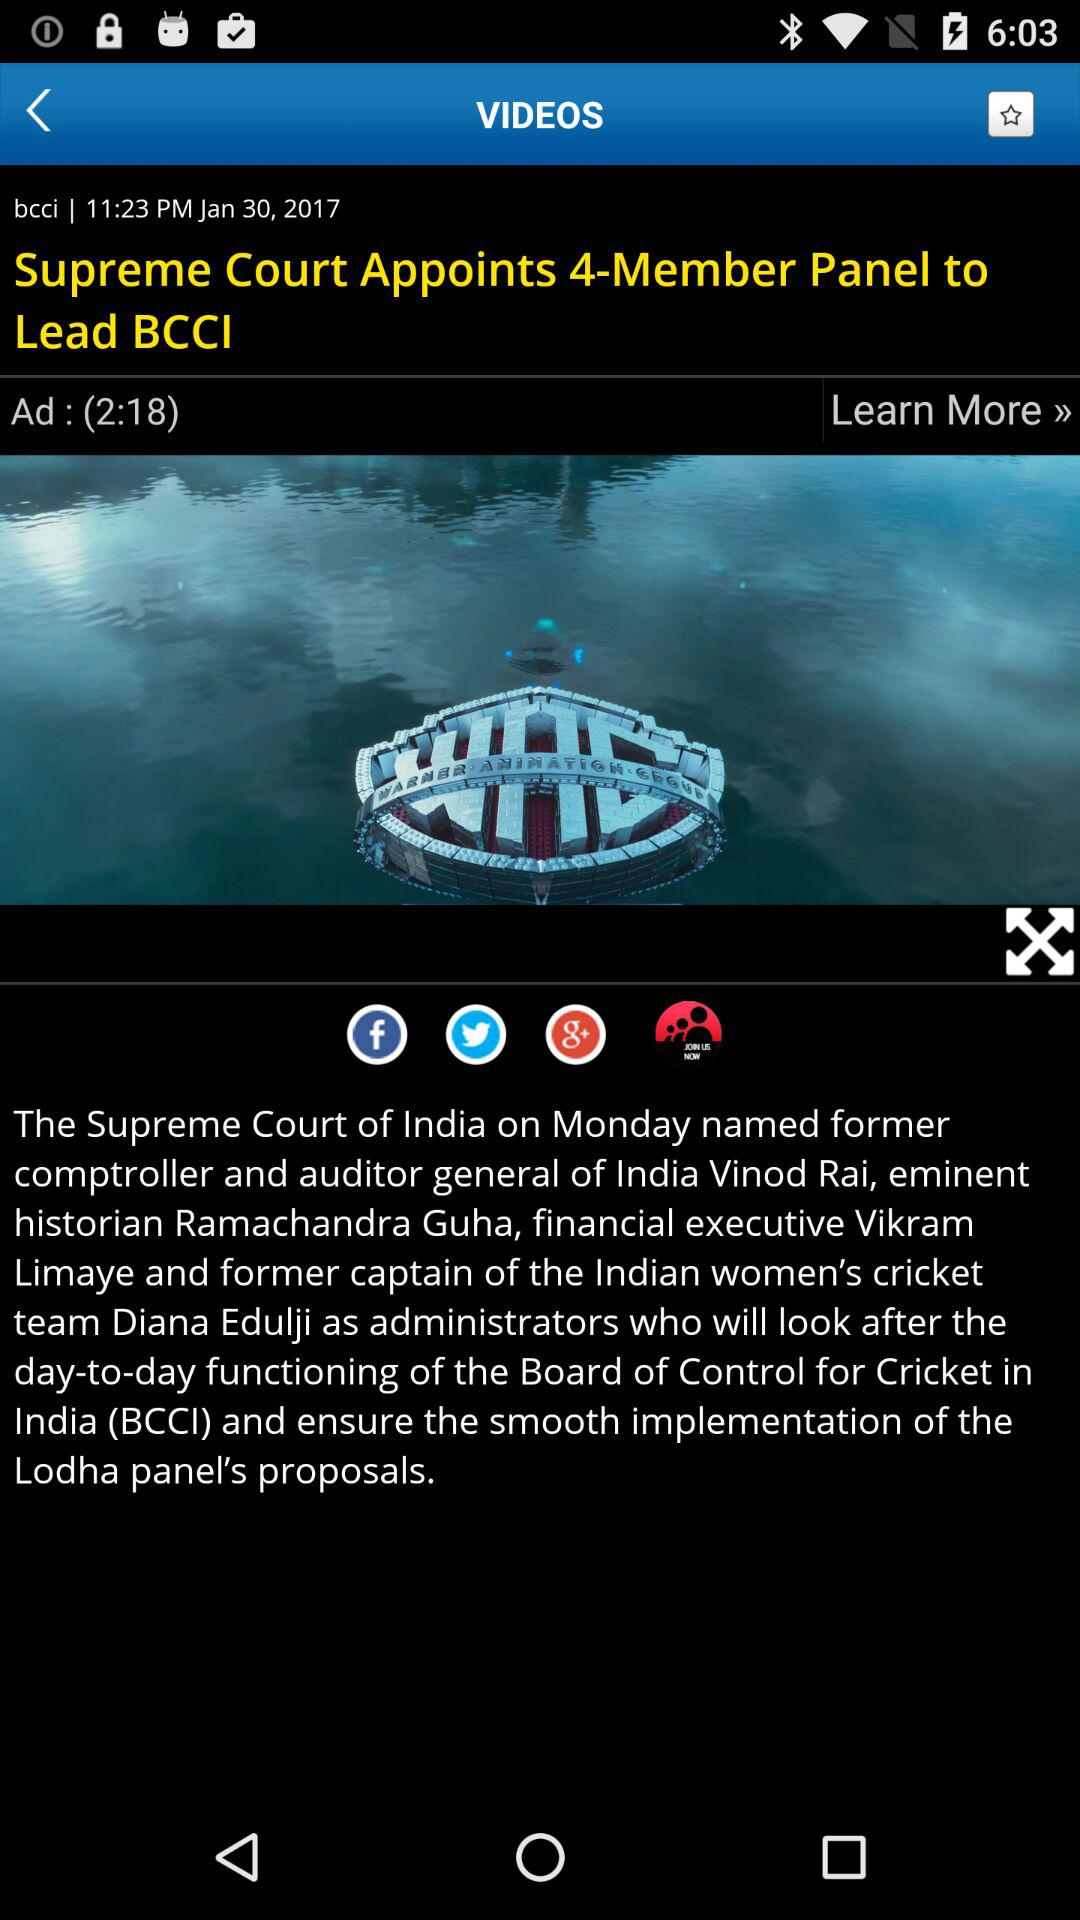What is the full form of the BCCI? The full form of the BCCI is "Board of Control for Cricket in India". 